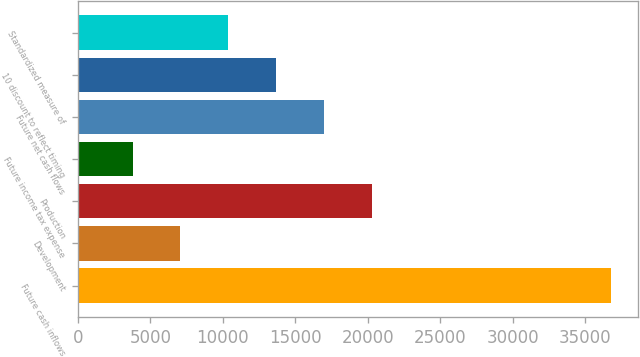Convert chart to OTSL. <chart><loc_0><loc_0><loc_500><loc_500><bar_chart><fcel>Future cash inflows<fcel>Development<fcel>Production<fcel>Future income tax expense<fcel>Future net cash flows<fcel>10 discount to reflect timing<fcel>Standardized measure of<nl><fcel>36786<fcel>7065.3<fcel>20274.5<fcel>3763<fcel>16972.2<fcel>13669.9<fcel>10367.6<nl></chart> 